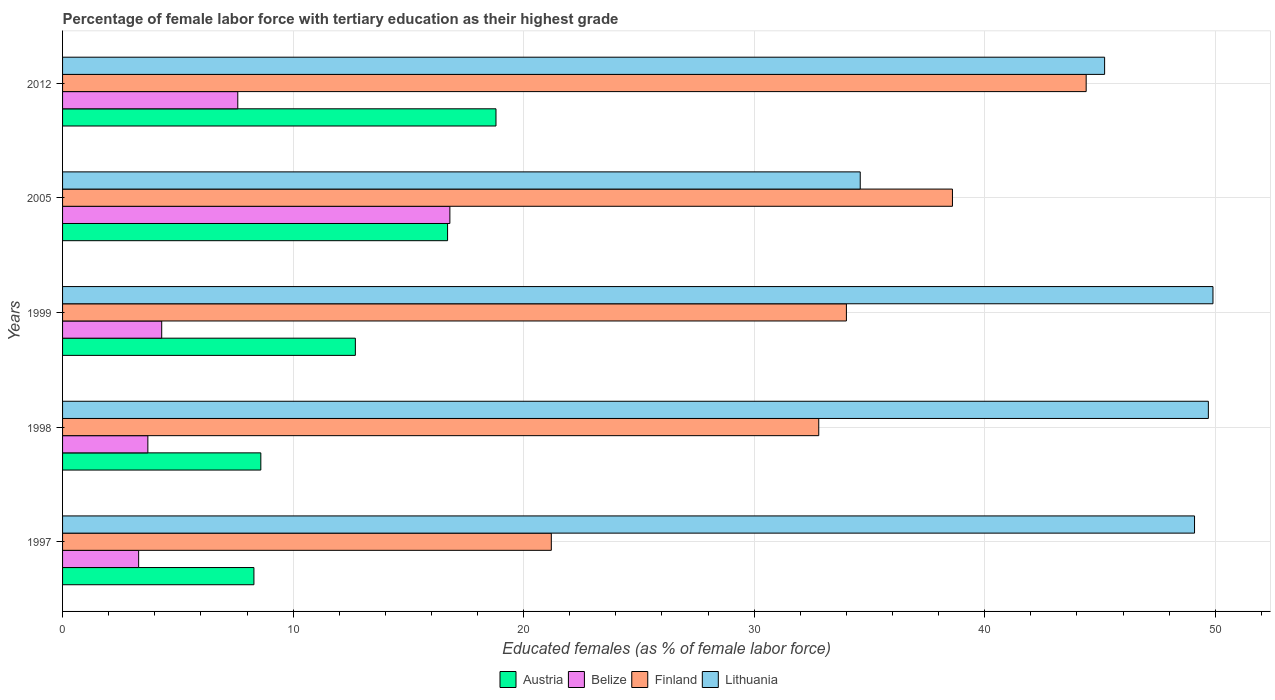Are the number of bars per tick equal to the number of legend labels?
Your response must be concise. Yes. Are the number of bars on each tick of the Y-axis equal?
Your response must be concise. Yes. How many bars are there on the 4th tick from the bottom?
Offer a terse response. 4. What is the label of the 4th group of bars from the top?
Your answer should be very brief. 1998. What is the percentage of female labor force with tertiary education in Lithuania in 1999?
Your response must be concise. 49.9. Across all years, what is the maximum percentage of female labor force with tertiary education in Finland?
Keep it short and to the point. 44.4. Across all years, what is the minimum percentage of female labor force with tertiary education in Austria?
Give a very brief answer. 8.3. In which year was the percentage of female labor force with tertiary education in Austria maximum?
Offer a very short reply. 2012. In which year was the percentage of female labor force with tertiary education in Lithuania minimum?
Provide a succinct answer. 2005. What is the total percentage of female labor force with tertiary education in Finland in the graph?
Give a very brief answer. 171. What is the difference between the percentage of female labor force with tertiary education in Belize in 2005 and that in 2012?
Your answer should be compact. 9.2. What is the difference between the percentage of female labor force with tertiary education in Belize in 1997 and the percentage of female labor force with tertiary education in Finland in 1999?
Provide a succinct answer. -30.7. What is the average percentage of female labor force with tertiary education in Belize per year?
Give a very brief answer. 7.14. In the year 2012, what is the difference between the percentage of female labor force with tertiary education in Belize and percentage of female labor force with tertiary education in Lithuania?
Make the answer very short. -37.6. What is the ratio of the percentage of female labor force with tertiary education in Belize in 1998 to that in 2012?
Your answer should be compact. 0.49. Is the difference between the percentage of female labor force with tertiary education in Belize in 1997 and 2005 greater than the difference between the percentage of female labor force with tertiary education in Lithuania in 1997 and 2005?
Provide a short and direct response. No. What is the difference between the highest and the second highest percentage of female labor force with tertiary education in Austria?
Provide a short and direct response. 2.1. What is the difference between the highest and the lowest percentage of female labor force with tertiary education in Austria?
Give a very brief answer. 10.5. In how many years, is the percentage of female labor force with tertiary education in Austria greater than the average percentage of female labor force with tertiary education in Austria taken over all years?
Provide a short and direct response. 2. What does the 3rd bar from the top in 2005 represents?
Give a very brief answer. Belize. Is it the case that in every year, the sum of the percentage of female labor force with tertiary education in Lithuania and percentage of female labor force with tertiary education in Austria is greater than the percentage of female labor force with tertiary education in Finland?
Your answer should be compact. Yes. How many bars are there?
Keep it short and to the point. 20. Are all the bars in the graph horizontal?
Ensure brevity in your answer.  Yes. How many years are there in the graph?
Offer a terse response. 5. What is the difference between two consecutive major ticks on the X-axis?
Your answer should be very brief. 10. Are the values on the major ticks of X-axis written in scientific E-notation?
Provide a succinct answer. No. Does the graph contain grids?
Make the answer very short. Yes. Where does the legend appear in the graph?
Your answer should be compact. Bottom center. How many legend labels are there?
Keep it short and to the point. 4. What is the title of the graph?
Keep it short and to the point. Percentage of female labor force with tertiary education as their highest grade. What is the label or title of the X-axis?
Your response must be concise. Educated females (as % of female labor force). What is the label or title of the Y-axis?
Your answer should be very brief. Years. What is the Educated females (as % of female labor force) of Austria in 1997?
Your answer should be compact. 8.3. What is the Educated females (as % of female labor force) in Belize in 1997?
Keep it short and to the point. 3.3. What is the Educated females (as % of female labor force) in Finland in 1997?
Your response must be concise. 21.2. What is the Educated females (as % of female labor force) of Lithuania in 1997?
Keep it short and to the point. 49.1. What is the Educated females (as % of female labor force) in Austria in 1998?
Offer a terse response. 8.6. What is the Educated females (as % of female labor force) in Belize in 1998?
Your answer should be very brief. 3.7. What is the Educated females (as % of female labor force) of Finland in 1998?
Provide a short and direct response. 32.8. What is the Educated females (as % of female labor force) in Lithuania in 1998?
Provide a short and direct response. 49.7. What is the Educated females (as % of female labor force) of Austria in 1999?
Make the answer very short. 12.7. What is the Educated females (as % of female labor force) in Belize in 1999?
Provide a succinct answer. 4.3. What is the Educated females (as % of female labor force) of Finland in 1999?
Make the answer very short. 34. What is the Educated females (as % of female labor force) of Lithuania in 1999?
Your answer should be very brief. 49.9. What is the Educated females (as % of female labor force) in Austria in 2005?
Your response must be concise. 16.7. What is the Educated females (as % of female labor force) of Belize in 2005?
Give a very brief answer. 16.8. What is the Educated females (as % of female labor force) of Finland in 2005?
Provide a succinct answer. 38.6. What is the Educated females (as % of female labor force) in Lithuania in 2005?
Your answer should be compact. 34.6. What is the Educated females (as % of female labor force) in Austria in 2012?
Make the answer very short. 18.8. What is the Educated females (as % of female labor force) of Belize in 2012?
Make the answer very short. 7.6. What is the Educated females (as % of female labor force) of Finland in 2012?
Your answer should be compact. 44.4. What is the Educated females (as % of female labor force) of Lithuania in 2012?
Offer a very short reply. 45.2. Across all years, what is the maximum Educated females (as % of female labor force) of Austria?
Offer a very short reply. 18.8. Across all years, what is the maximum Educated females (as % of female labor force) of Belize?
Provide a succinct answer. 16.8. Across all years, what is the maximum Educated females (as % of female labor force) of Finland?
Make the answer very short. 44.4. Across all years, what is the maximum Educated females (as % of female labor force) in Lithuania?
Your answer should be very brief. 49.9. Across all years, what is the minimum Educated females (as % of female labor force) in Austria?
Your answer should be very brief. 8.3. Across all years, what is the minimum Educated females (as % of female labor force) of Belize?
Provide a short and direct response. 3.3. Across all years, what is the minimum Educated females (as % of female labor force) of Finland?
Make the answer very short. 21.2. Across all years, what is the minimum Educated females (as % of female labor force) in Lithuania?
Keep it short and to the point. 34.6. What is the total Educated females (as % of female labor force) of Austria in the graph?
Give a very brief answer. 65.1. What is the total Educated females (as % of female labor force) in Belize in the graph?
Your response must be concise. 35.7. What is the total Educated females (as % of female labor force) in Finland in the graph?
Give a very brief answer. 171. What is the total Educated females (as % of female labor force) in Lithuania in the graph?
Offer a terse response. 228.5. What is the difference between the Educated females (as % of female labor force) in Austria in 1997 and that in 1998?
Your answer should be very brief. -0.3. What is the difference between the Educated females (as % of female labor force) of Belize in 1997 and that in 1999?
Offer a very short reply. -1. What is the difference between the Educated females (as % of female labor force) of Finland in 1997 and that in 1999?
Your answer should be very brief. -12.8. What is the difference between the Educated females (as % of female labor force) of Lithuania in 1997 and that in 1999?
Your answer should be compact. -0.8. What is the difference between the Educated females (as % of female labor force) in Finland in 1997 and that in 2005?
Offer a terse response. -17.4. What is the difference between the Educated females (as % of female labor force) in Lithuania in 1997 and that in 2005?
Keep it short and to the point. 14.5. What is the difference between the Educated females (as % of female labor force) in Finland in 1997 and that in 2012?
Your response must be concise. -23.2. What is the difference between the Educated females (as % of female labor force) of Lithuania in 1997 and that in 2012?
Provide a short and direct response. 3.9. What is the difference between the Educated females (as % of female labor force) of Lithuania in 1998 and that in 1999?
Your answer should be very brief. -0.2. What is the difference between the Educated females (as % of female labor force) of Finland in 1998 and that in 2005?
Give a very brief answer. -5.8. What is the difference between the Educated females (as % of female labor force) in Lithuania in 1998 and that in 2005?
Make the answer very short. 15.1. What is the difference between the Educated females (as % of female labor force) of Lithuania in 1998 and that in 2012?
Offer a very short reply. 4.5. What is the difference between the Educated females (as % of female labor force) of Belize in 1999 and that in 2005?
Make the answer very short. -12.5. What is the difference between the Educated females (as % of female labor force) of Austria in 1999 and that in 2012?
Provide a short and direct response. -6.1. What is the difference between the Educated females (as % of female labor force) of Belize in 1999 and that in 2012?
Your response must be concise. -3.3. What is the difference between the Educated females (as % of female labor force) of Finland in 1999 and that in 2012?
Keep it short and to the point. -10.4. What is the difference between the Educated females (as % of female labor force) of Belize in 2005 and that in 2012?
Give a very brief answer. 9.2. What is the difference between the Educated females (as % of female labor force) of Lithuania in 2005 and that in 2012?
Your response must be concise. -10.6. What is the difference between the Educated females (as % of female labor force) of Austria in 1997 and the Educated females (as % of female labor force) of Finland in 1998?
Make the answer very short. -24.5. What is the difference between the Educated females (as % of female labor force) in Austria in 1997 and the Educated females (as % of female labor force) in Lithuania in 1998?
Your answer should be very brief. -41.4. What is the difference between the Educated females (as % of female labor force) in Belize in 1997 and the Educated females (as % of female labor force) in Finland in 1998?
Ensure brevity in your answer.  -29.5. What is the difference between the Educated females (as % of female labor force) of Belize in 1997 and the Educated females (as % of female labor force) of Lithuania in 1998?
Ensure brevity in your answer.  -46.4. What is the difference between the Educated females (as % of female labor force) of Finland in 1997 and the Educated females (as % of female labor force) of Lithuania in 1998?
Keep it short and to the point. -28.5. What is the difference between the Educated females (as % of female labor force) of Austria in 1997 and the Educated females (as % of female labor force) of Belize in 1999?
Provide a short and direct response. 4. What is the difference between the Educated females (as % of female labor force) in Austria in 1997 and the Educated females (as % of female labor force) in Finland in 1999?
Ensure brevity in your answer.  -25.7. What is the difference between the Educated females (as % of female labor force) in Austria in 1997 and the Educated females (as % of female labor force) in Lithuania in 1999?
Give a very brief answer. -41.6. What is the difference between the Educated females (as % of female labor force) of Belize in 1997 and the Educated females (as % of female labor force) of Finland in 1999?
Your response must be concise. -30.7. What is the difference between the Educated females (as % of female labor force) of Belize in 1997 and the Educated females (as % of female labor force) of Lithuania in 1999?
Give a very brief answer. -46.6. What is the difference between the Educated females (as % of female labor force) in Finland in 1997 and the Educated females (as % of female labor force) in Lithuania in 1999?
Provide a short and direct response. -28.7. What is the difference between the Educated females (as % of female labor force) in Austria in 1997 and the Educated females (as % of female labor force) in Belize in 2005?
Keep it short and to the point. -8.5. What is the difference between the Educated females (as % of female labor force) of Austria in 1997 and the Educated females (as % of female labor force) of Finland in 2005?
Offer a terse response. -30.3. What is the difference between the Educated females (as % of female labor force) in Austria in 1997 and the Educated females (as % of female labor force) in Lithuania in 2005?
Your answer should be very brief. -26.3. What is the difference between the Educated females (as % of female labor force) in Belize in 1997 and the Educated females (as % of female labor force) in Finland in 2005?
Make the answer very short. -35.3. What is the difference between the Educated females (as % of female labor force) of Belize in 1997 and the Educated females (as % of female labor force) of Lithuania in 2005?
Offer a very short reply. -31.3. What is the difference between the Educated females (as % of female labor force) of Austria in 1997 and the Educated females (as % of female labor force) of Belize in 2012?
Offer a very short reply. 0.7. What is the difference between the Educated females (as % of female labor force) in Austria in 1997 and the Educated females (as % of female labor force) in Finland in 2012?
Ensure brevity in your answer.  -36.1. What is the difference between the Educated females (as % of female labor force) of Austria in 1997 and the Educated females (as % of female labor force) of Lithuania in 2012?
Offer a very short reply. -36.9. What is the difference between the Educated females (as % of female labor force) of Belize in 1997 and the Educated females (as % of female labor force) of Finland in 2012?
Ensure brevity in your answer.  -41.1. What is the difference between the Educated females (as % of female labor force) in Belize in 1997 and the Educated females (as % of female labor force) in Lithuania in 2012?
Your answer should be very brief. -41.9. What is the difference between the Educated females (as % of female labor force) of Finland in 1997 and the Educated females (as % of female labor force) of Lithuania in 2012?
Your response must be concise. -24. What is the difference between the Educated females (as % of female labor force) in Austria in 1998 and the Educated females (as % of female labor force) in Finland in 1999?
Offer a very short reply. -25.4. What is the difference between the Educated females (as % of female labor force) in Austria in 1998 and the Educated females (as % of female labor force) in Lithuania in 1999?
Provide a short and direct response. -41.3. What is the difference between the Educated females (as % of female labor force) of Belize in 1998 and the Educated females (as % of female labor force) of Finland in 1999?
Your answer should be very brief. -30.3. What is the difference between the Educated females (as % of female labor force) of Belize in 1998 and the Educated females (as % of female labor force) of Lithuania in 1999?
Offer a terse response. -46.2. What is the difference between the Educated females (as % of female labor force) in Finland in 1998 and the Educated females (as % of female labor force) in Lithuania in 1999?
Provide a succinct answer. -17.1. What is the difference between the Educated females (as % of female labor force) in Austria in 1998 and the Educated females (as % of female labor force) in Belize in 2005?
Provide a succinct answer. -8.2. What is the difference between the Educated females (as % of female labor force) in Austria in 1998 and the Educated females (as % of female labor force) in Lithuania in 2005?
Ensure brevity in your answer.  -26. What is the difference between the Educated females (as % of female labor force) in Belize in 1998 and the Educated females (as % of female labor force) in Finland in 2005?
Offer a terse response. -34.9. What is the difference between the Educated females (as % of female labor force) in Belize in 1998 and the Educated females (as % of female labor force) in Lithuania in 2005?
Offer a terse response. -30.9. What is the difference between the Educated females (as % of female labor force) in Finland in 1998 and the Educated females (as % of female labor force) in Lithuania in 2005?
Keep it short and to the point. -1.8. What is the difference between the Educated females (as % of female labor force) of Austria in 1998 and the Educated females (as % of female labor force) of Belize in 2012?
Give a very brief answer. 1. What is the difference between the Educated females (as % of female labor force) of Austria in 1998 and the Educated females (as % of female labor force) of Finland in 2012?
Provide a succinct answer. -35.8. What is the difference between the Educated females (as % of female labor force) of Austria in 1998 and the Educated females (as % of female labor force) of Lithuania in 2012?
Offer a very short reply. -36.6. What is the difference between the Educated females (as % of female labor force) of Belize in 1998 and the Educated females (as % of female labor force) of Finland in 2012?
Make the answer very short. -40.7. What is the difference between the Educated females (as % of female labor force) in Belize in 1998 and the Educated females (as % of female labor force) in Lithuania in 2012?
Offer a terse response. -41.5. What is the difference between the Educated females (as % of female labor force) in Austria in 1999 and the Educated females (as % of female labor force) in Belize in 2005?
Keep it short and to the point. -4.1. What is the difference between the Educated females (as % of female labor force) of Austria in 1999 and the Educated females (as % of female labor force) of Finland in 2005?
Make the answer very short. -25.9. What is the difference between the Educated females (as % of female labor force) of Austria in 1999 and the Educated females (as % of female labor force) of Lithuania in 2005?
Offer a terse response. -21.9. What is the difference between the Educated females (as % of female labor force) in Belize in 1999 and the Educated females (as % of female labor force) in Finland in 2005?
Your answer should be compact. -34.3. What is the difference between the Educated females (as % of female labor force) in Belize in 1999 and the Educated females (as % of female labor force) in Lithuania in 2005?
Offer a very short reply. -30.3. What is the difference between the Educated females (as % of female labor force) in Finland in 1999 and the Educated females (as % of female labor force) in Lithuania in 2005?
Offer a very short reply. -0.6. What is the difference between the Educated females (as % of female labor force) in Austria in 1999 and the Educated females (as % of female labor force) in Finland in 2012?
Make the answer very short. -31.7. What is the difference between the Educated females (as % of female labor force) in Austria in 1999 and the Educated females (as % of female labor force) in Lithuania in 2012?
Offer a terse response. -32.5. What is the difference between the Educated females (as % of female labor force) in Belize in 1999 and the Educated females (as % of female labor force) in Finland in 2012?
Offer a very short reply. -40.1. What is the difference between the Educated females (as % of female labor force) of Belize in 1999 and the Educated females (as % of female labor force) of Lithuania in 2012?
Provide a succinct answer. -40.9. What is the difference between the Educated females (as % of female labor force) of Finland in 1999 and the Educated females (as % of female labor force) of Lithuania in 2012?
Give a very brief answer. -11.2. What is the difference between the Educated females (as % of female labor force) of Austria in 2005 and the Educated females (as % of female labor force) of Belize in 2012?
Your answer should be very brief. 9.1. What is the difference between the Educated females (as % of female labor force) in Austria in 2005 and the Educated females (as % of female labor force) in Finland in 2012?
Your response must be concise. -27.7. What is the difference between the Educated females (as % of female labor force) of Austria in 2005 and the Educated females (as % of female labor force) of Lithuania in 2012?
Your answer should be very brief. -28.5. What is the difference between the Educated females (as % of female labor force) of Belize in 2005 and the Educated females (as % of female labor force) of Finland in 2012?
Provide a succinct answer. -27.6. What is the difference between the Educated females (as % of female labor force) in Belize in 2005 and the Educated females (as % of female labor force) in Lithuania in 2012?
Offer a terse response. -28.4. What is the difference between the Educated females (as % of female labor force) of Finland in 2005 and the Educated females (as % of female labor force) of Lithuania in 2012?
Provide a short and direct response. -6.6. What is the average Educated females (as % of female labor force) in Austria per year?
Give a very brief answer. 13.02. What is the average Educated females (as % of female labor force) of Belize per year?
Offer a terse response. 7.14. What is the average Educated females (as % of female labor force) in Finland per year?
Offer a very short reply. 34.2. What is the average Educated females (as % of female labor force) of Lithuania per year?
Give a very brief answer. 45.7. In the year 1997, what is the difference between the Educated females (as % of female labor force) of Austria and Educated females (as % of female labor force) of Belize?
Ensure brevity in your answer.  5. In the year 1997, what is the difference between the Educated females (as % of female labor force) of Austria and Educated females (as % of female labor force) of Lithuania?
Your answer should be very brief. -40.8. In the year 1997, what is the difference between the Educated females (as % of female labor force) in Belize and Educated females (as % of female labor force) in Finland?
Your response must be concise. -17.9. In the year 1997, what is the difference between the Educated females (as % of female labor force) of Belize and Educated females (as % of female labor force) of Lithuania?
Provide a short and direct response. -45.8. In the year 1997, what is the difference between the Educated females (as % of female labor force) in Finland and Educated females (as % of female labor force) in Lithuania?
Your answer should be compact. -27.9. In the year 1998, what is the difference between the Educated females (as % of female labor force) of Austria and Educated females (as % of female labor force) of Belize?
Give a very brief answer. 4.9. In the year 1998, what is the difference between the Educated females (as % of female labor force) of Austria and Educated females (as % of female labor force) of Finland?
Make the answer very short. -24.2. In the year 1998, what is the difference between the Educated females (as % of female labor force) in Austria and Educated females (as % of female labor force) in Lithuania?
Make the answer very short. -41.1. In the year 1998, what is the difference between the Educated females (as % of female labor force) in Belize and Educated females (as % of female labor force) in Finland?
Your answer should be compact. -29.1. In the year 1998, what is the difference between the Educated females (as % of female labor force) in Belize and Educated females (as % of female labor force) in Lithuania?
Provide a short and direct response. -46. In the year 1998, what is the difference between the Educated females (as % of female labor force) in Finland and Educated females (as % of female labor force) in Lithuania?
Offer a terse response. -16.9. In the year 1999, what is the difference between the Educated females (as % of female labor force) of Austria and Educated females (as % of female labor force) of Finland?
Offer a very short reply. -21.3. In the year 1999, what is the difference between the Educated females (as % of female labor force) of Austria and Educated females (as % of female labor force) of Lithuania?
Provide a succinct answer. -37.2. In the year 1999, what is the difference between the Educated females (as % of female labor force) of Belize and Educated females (as % of female labor force) of Finland?
Offer a terse response. -29.7. In the year 1999, what is the difference between the Educated females (as % of female labor force) in Belize and Educated females (as % of female labor force) in Lithuania?
Your answer should be compact. -45.6. In the year 1999, what is the difference between the Educated females (as % of female labor force) of Finland and Educated females (as % of female labor force) of Lithuania?
Your response must be concise. -15.9. In the year 2005, what is the difference between the Educated females (as % of female labor force) in Austria and Educated females (as % of female labor force) in Belize?
Give a very brief answer. -0.1. In the year 2005, what is the difference between the Educated females (as % of female labor force) of Austria and Educated females (as % of female labor force) of Finland?
Offer a terse response. -21.9. In the year 2005, what is the difference between the Educated females (as % of female labor force) in Austria and Educated females (as % of female labor force) in Lithuania?
Your answer should be compact. -17.9. In the year 2005, what is the difference between the Educated females (as % of female labor force) in Belize and Educated females (as % of female labor force) in Finland?
Give a very brief answer. -21.8. In the year 2005, what is the difference between the Educated females (as % of female labor force) of Belize and Educated females (as % of female labor force) of Lithuania?
Provide a short and direct response. -17.8. In the year 2005, what is the difference between the Educated females (as % of female labor force) of Finland and Educated females (as % of female labor force) of Lithuania?
Provide a short and direct response. 4. In the year 2012, what is the difference between the Educated females (as % of female labor force) of Austria and Educated females (as % of female labor force) of Belize?
Your response must be concise. 11.2. In the year 2012, what is the difference between the Educated females (as % of female labor force) of Austria and Educated females (as % of female labor force) of Finland?
Offer a terse response. -25.6. In the year 2012, what is the difference between the Educated females (as % of female labor force) of Austria and Educated females (as % of female labor force) of Lithuania?
Offer a very short reply. -26.4. In the year 2012, what is the difference between the Educated females (as % of female labor force) in Belize and Educated females (as % of female labor force) in Finland?
Offer a very short reply. -36.8. In the year 2012, what is the difference between the Educated females (as % of female labor force) in Belize and Educated females (as % of female labor force) in Lithuania?
Your response must be concise. -37.6. What is the ratio of the Educated females (as % of female labor force) in Austria in 1997 to that in 1998?
Keep it short and to the point. 0.97. What is the ratio of the Educated females (as % of female labor force) of Belize in 1997 to that in 1998?
Keep it short and to the point. 0.89. What is the ratio of the Educated females (as % of female labor force) in Finland in 1997 to that in 1998?
Your response must be concise. 0.65. What is the ratio of the Educated females (as % of female labor force) of Lithuania in 1997 to that in 1998?
Provide a short and direct response. 0.99. What is the ratio of the Educated females (as % of female labor force) in Austria in 1997 to that in 1999?
Your response must be concise. 0.65. What is the ratio of the Educated females (as % of female labor force) of Belize in 1997 to that in 1999?
Make the answer very short. 0.77. What is the ratio of the Educated females (as % of female labor force) in Finland in 1997 to that in 1999?
Ensure brevity in your answer.  0.62. What is the ratio of the Educated females (as % of female labor force) in Austria in 1997 to that in 2005?
Offer a very short reply. 0.5. What is the ratio of the Educated females (as % of female labor force) of Belize in 1997 to that in 2005?
Your response must be concise. 0.2. What is the ratio of the Educated females (as % of female labor force) in Finland in 1997 to that in 2005?
Your answer should be very brief. 0.55. What is the ratio of the Educated females (as % of female labor force) in Lithuania in 1997 to that in 2005?
Provide a succinct answer. 1.42. What is the ratio of the Educated females (as % of female labor force) of Austria in 1997 to that in 2012?
Offer a terse response. 0.44. What is the ratio of the Educated females (as % of female labor force) in Belize in 1997 to that in 2012?
Keep it short and to the point. 0.43. What is the ratio of the Educated females (as % of female labor force) in Finland in 1997 to that in 2012?
Provide a succinct answer. 0.48. What is the ratio of the Educated females (as % of female labor force) of Lithuania in 1997 to that in 2012?
Provide a short and direct response. 1.09. What is the ratio of the Educated females (as % of female labor force) in Austria in 1998 to that in 1999?
Your answer should be very brief. 0.68. What is the ratio of the Educated females (as % of female labor force) of Belize in 1998 to that in 1999?
Keep it short and to the point. 0.86. What is the ratio of the Educated females (as % of female labor force) in Finland in 1998 to that in 1999?
Keep it short and to the point. 0.96. What is the ratio of the Educated females (as % of female labor force) in Austria in 1998 to that in 2005?
Keep it short and to the point. 0.52. What is the ratio of the Educated females (as % of female labor force) of Belize in 1998 to that in 2005?
Make the answer very short. 0.22. What is the ratio of the Educated females (as % of female labor force) of Finland in 1998 to that in 2005?
Make the answer very short. 0.85. What is the ratio of the Educated females (as % of female labor force) in Lithuania in 1998 to that in 2005?
Offer a terse response. 1.44. What is the ratio of the Educated females (as % of female labor force) in Austria in 1998 to that in 2012?
Ensure brevity in your answer.  0.46. What is the ratio of the Educated females (as % of female labor force) of Belize in 1998 to that in 2012?
Provide a succinct answer. 0.49. What is the ratio of the Educated females (as % of female labor force) in Finland in 1998 to that in 2012?
Offer a very short reply. 0.74. What is the ratio of the Educated females (as % of female labor force) of Lithuania in 1998 to that in 2012?
Your answer should be very brief. 1.1. What is the ratio of the Educated females (as % of female labor force) in Austria in 1999 to that in 2005?
Your answer should be compact. 0.76. What is the ratio of the Educated females (as % of female labor force) in Belize in 1999 to that in 2005?
Keep it short and to the point. 0.26. What is the ratio of the Educated females (as % of female labor force) of Finland in 1999 to that in 2005?
Make the answer very short. 0.88. What is the ratio of the Educated females (as % of female labor force) in Lithuania in 1999 to that in 2005?
Offer a very short reply. 1.44. What is the ratio of the Educated females (as % of female labor force) in Austria in 1999 to that in 2012?
Your answer should be very brief. 0.68. What is the ratio of the Educated females (as % of female labor force) of Belize in 1999 to that in 2012?
Provide a short and direct response. 0.57. What is the ratio of the Educated females (as % of female labor force) of Finland in 1999 to that in 2012?
Your response must be concise. 0.77. What is the ratio of the Educated females (as % of female labor force) of Lithuania in 1999 to that in 2012?
Provide a succinct answer. 1.1. What is the ratio of the Educated females (as % of female labor force) in Austria in 2005 to that in 2012?
Provide a succinct answer. 0.89. What is the ratio of the Educated females (as % of female labor force) in Belize in 2005 to that in 2012?
Make the answer very short. 2.21. What is the ratio of the Educated females (as % of female labor force) of Finland in 2005 to that in 2012?
Your answer should be very brief. 0.87. What is the ratio of the Educated females (as % of female labor force) of Lithuania in 2005 to that in 2012?
Your answer should be compact. 0.77. What is the difference between the highest and the second highest Educated females (as % of female labor force) of Austria?
Ensure brevity in your answer.  2.1. What is the difference between the highest and the second highest Educated females (as % of female labor force) in Lithuania?
Provide a short and direct response. 0.2. What is the difference between the highest and the lowest Educated females (as % of female labor force) of Belize?
Offer a terse response. 13.5. What is the difference between the highest and the lowest Educated females (as % of female labor force) of Finland?
Offer a terse response. 23.2. 